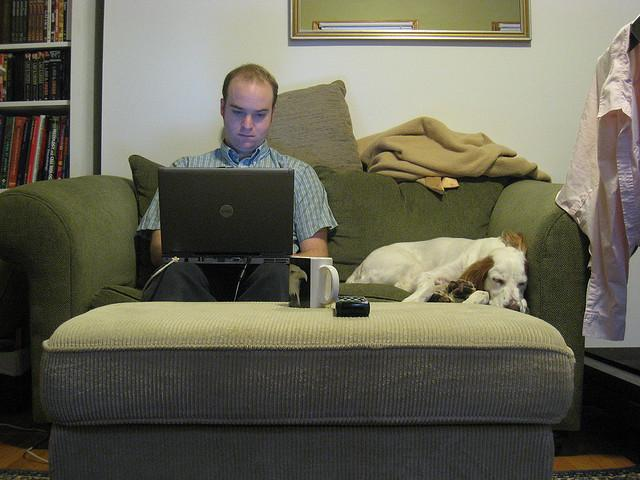What type of potentially harmful light does the laptop screen produce? Please explain your reasoning. uv rays. The uv rays are harmful. 